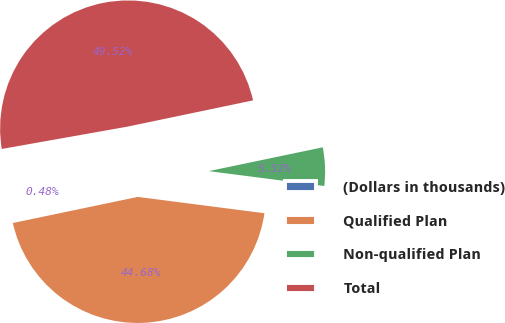Convert chart. <chart><loc_0><loc_0><loc_500><loc_500><pie_chart><fcel>(Dollars in thousands)<fcel>Qualified Plan<fcel>Non-qualified Plan<fcel>Total<nl><fcel>0.48%<fcel>44.68%<fcel>5.32%<fcel>49.52%<nl></chart> 